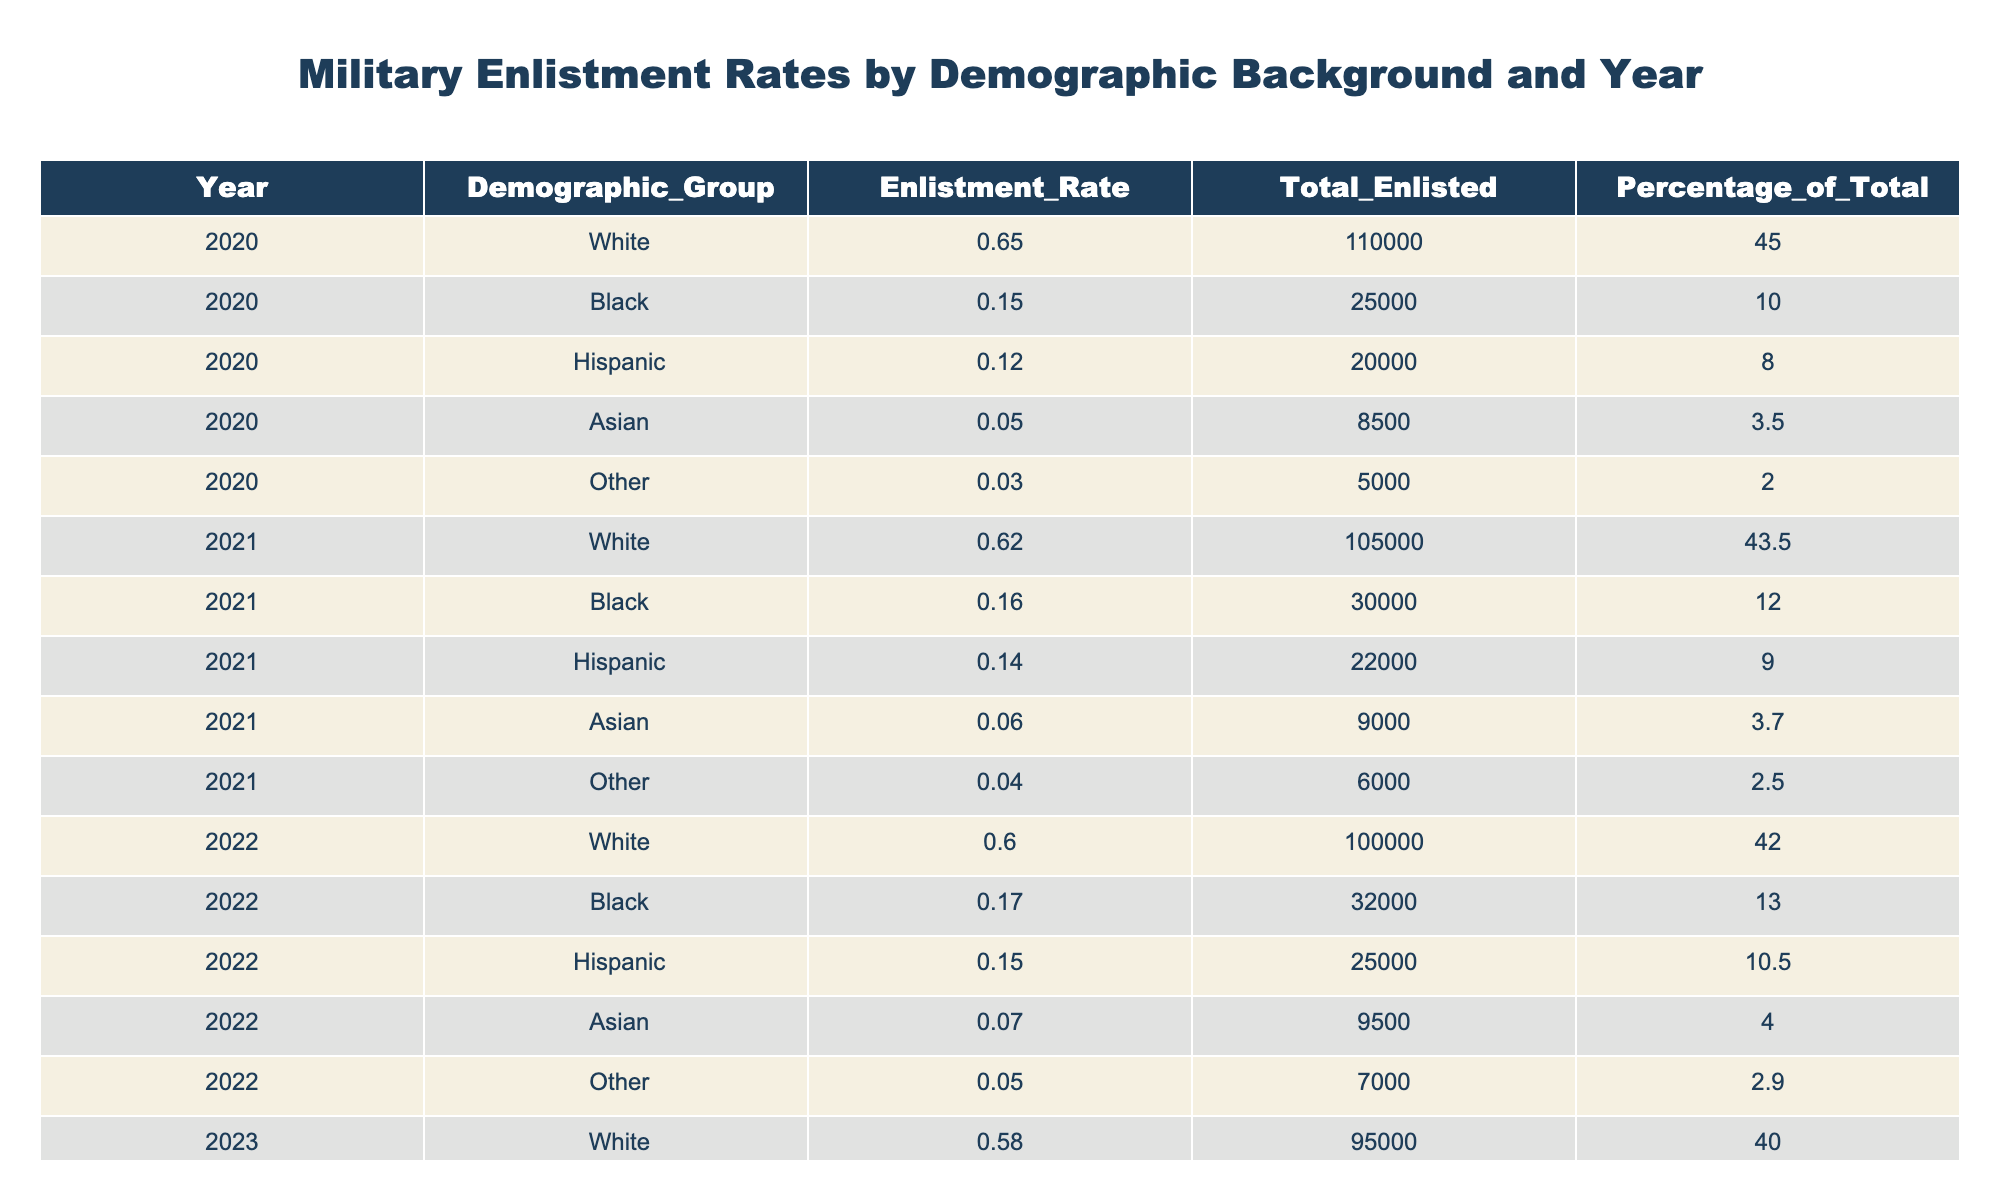What was the enlistment rate for Black service members in 2022? In the table, I look for the row corresponding to the year 2022 and the demographic group Black. The enlistment rate listed there is 0.17.
Answer: 0.17 What percentage of the total enlistment in 2020 was from the White demographic group? I can find the row for the White demographic group in 2020, which states that the percentage of total enlistment is 45.0.
Answer: 45.0 Which demographic group had the highest total enlisted in 2021? I examine the total enlisted column for all demographic groups in 2021. The White demographic group has the highest number at 105000.
Answer: White What was the combined total enlisted for Hispanic and Black service members in 2023? I will check the total enlisted for both Hispanic (27000) and Black (35000) in 2023, then sum these two values: 27000 + 35000 = 62000.
Answer: 62000 Did the enlistment rate for Asian service members increase from 2020 to 2023? The enlistment rates for Asian service members in 2020 and 2023 are 0.05 and 0.08, respectively. Since 0.08 is greater than 0.05, it indicates an increase.
Answer: Yes What was the average enlistment rate across all demographic groups in 2021? I will add the enlistment rates for all groups in 2021: 0.62 (White) + 0.16 (Black) + 0.14 (Hispanic) + 0.06 (Asian) + 0.04 (Other) = 1.02. Then, divide by the number of groups (5): 1.02 / 5 = 0.204.
Answer: 0.204 Which year saw the greatest increase in enlistment rates for Hispanic service members? First, I compare the enlistment rates for Hispanic service members across the years: 2020 has 0.12, 2021 has 0.14, 2022 has 0.15, and 2023 has 0.16. The rate increased from 0.12 to 0.16 from 2020 to 2023, indicating that the greatest increase happened in those years.
Answer: 2020 to 2023 What is the total enlisted number for the 'Other' demographic group across all years? I locate the total enlisted numbers for the 'Other' demographic across the years: 5000 (2020), 6000 (2021), 7000 (2022), and 8000 (2023). Summing these values gives: 5000 + 6000 + 7000 + 8000 = 26000.
Answer: 26000 